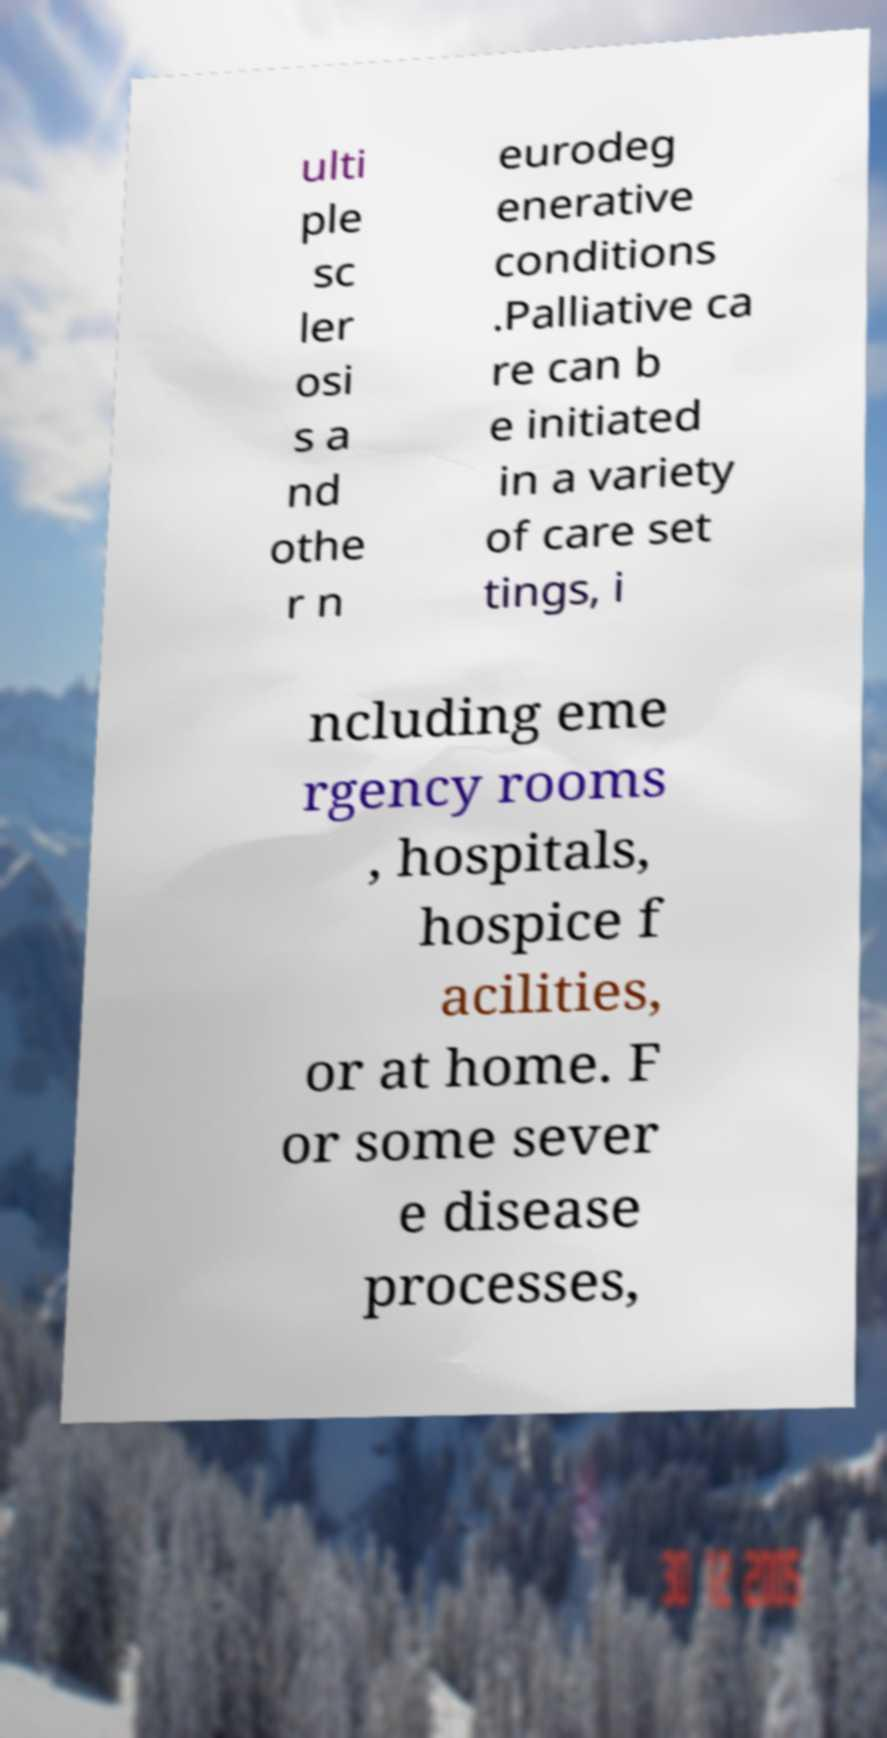Please read and relay the text visible in this image. What does it say? ulti ple sc ler osi s a nd othe r n eurodeg enerative conditions .Palliative ca re can b e initiated in a variety of care set tings, i ncluding eme rgency rooms , hospitals, hospice f acilities, or at home. F or some sever e disease processes, 